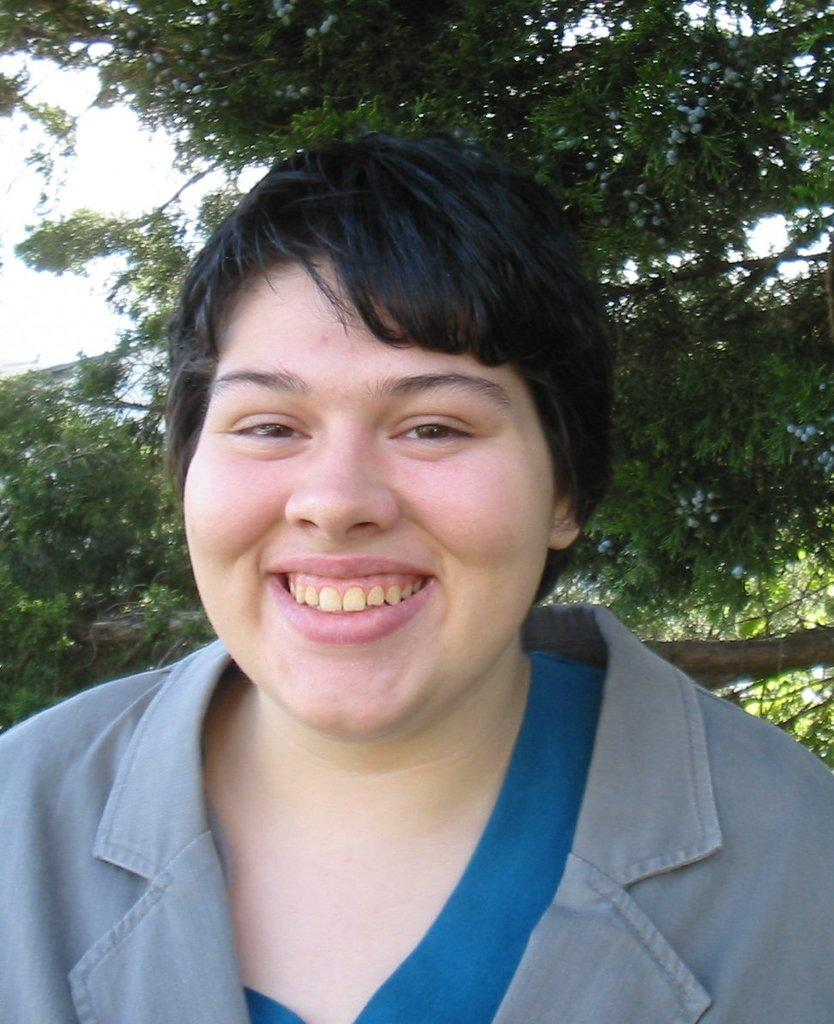Who or what is present in the image? There is a person in the image. What is the person doing or expressing? The person is smiling. What can be seen in the background of the image? There are trees and the sky visible in the background of the image. Reasoning: Let's think step by breaking down the conversation step by step. We start by identifying the main subject in the image, which is the person. Then, we describe the person's expression, which is smiling. Finally, we mention the background elements, which are trees and the sky. Each question is designed to elicit a specific detail about the image that is known from the provided facts. Absurd Question/Answer: What is the price of the lamp in the image? There is no lamp present in the image, so it is not possible to determine its price. 